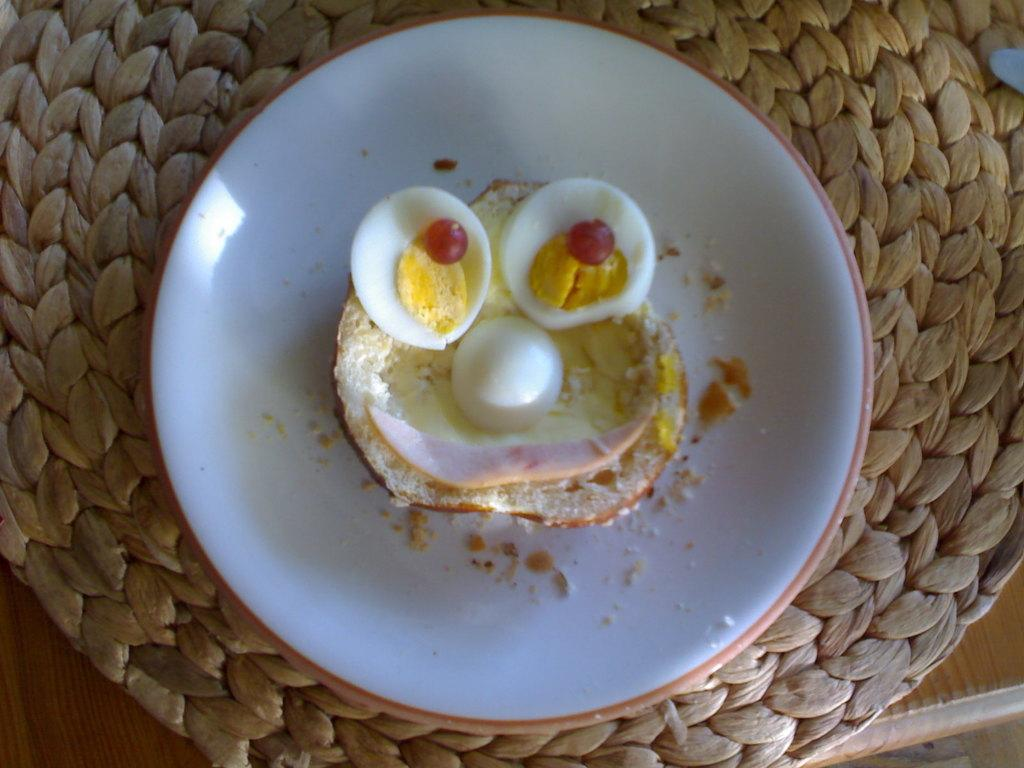What is located in the center of the image? There is a basket in the center of the image. What is inside the basket? There is a plate inside the basket. What is on the plate? There is food on the plate. Where is the table in relation to the basket? The table is at the bottom of the image. Can you see your dad playing in the park in the image? There is no reference to a dad or a park in the image; it features a basket with a plate and food on a table. 